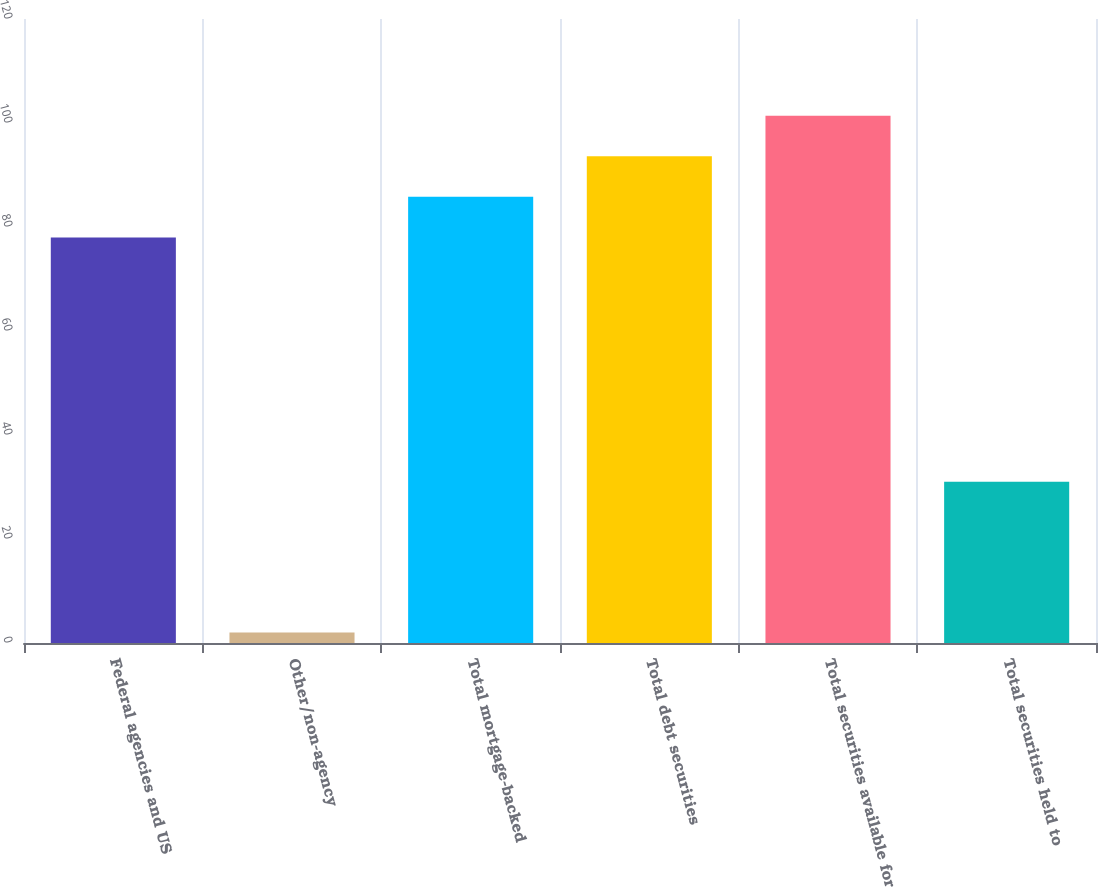<chart> <loc_0><loc_0><loc_500><loc_500><bar_chart><fcel>Federal agencies and US<fcel>Other/non-agency<fcel>Total mortgage-backed<fcel>Total debt securities<fcel>Total securities available for<fcel>Total securities held to<nl><fcel>78<fcel>2<fcel>85.8<fcel>93.6<fcel>101.4<fcel>31<nl></chart> 